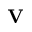Convert formula to latex. <formula><loc_0><loc_0><loc_500><loc_500>{ V }</formula> 